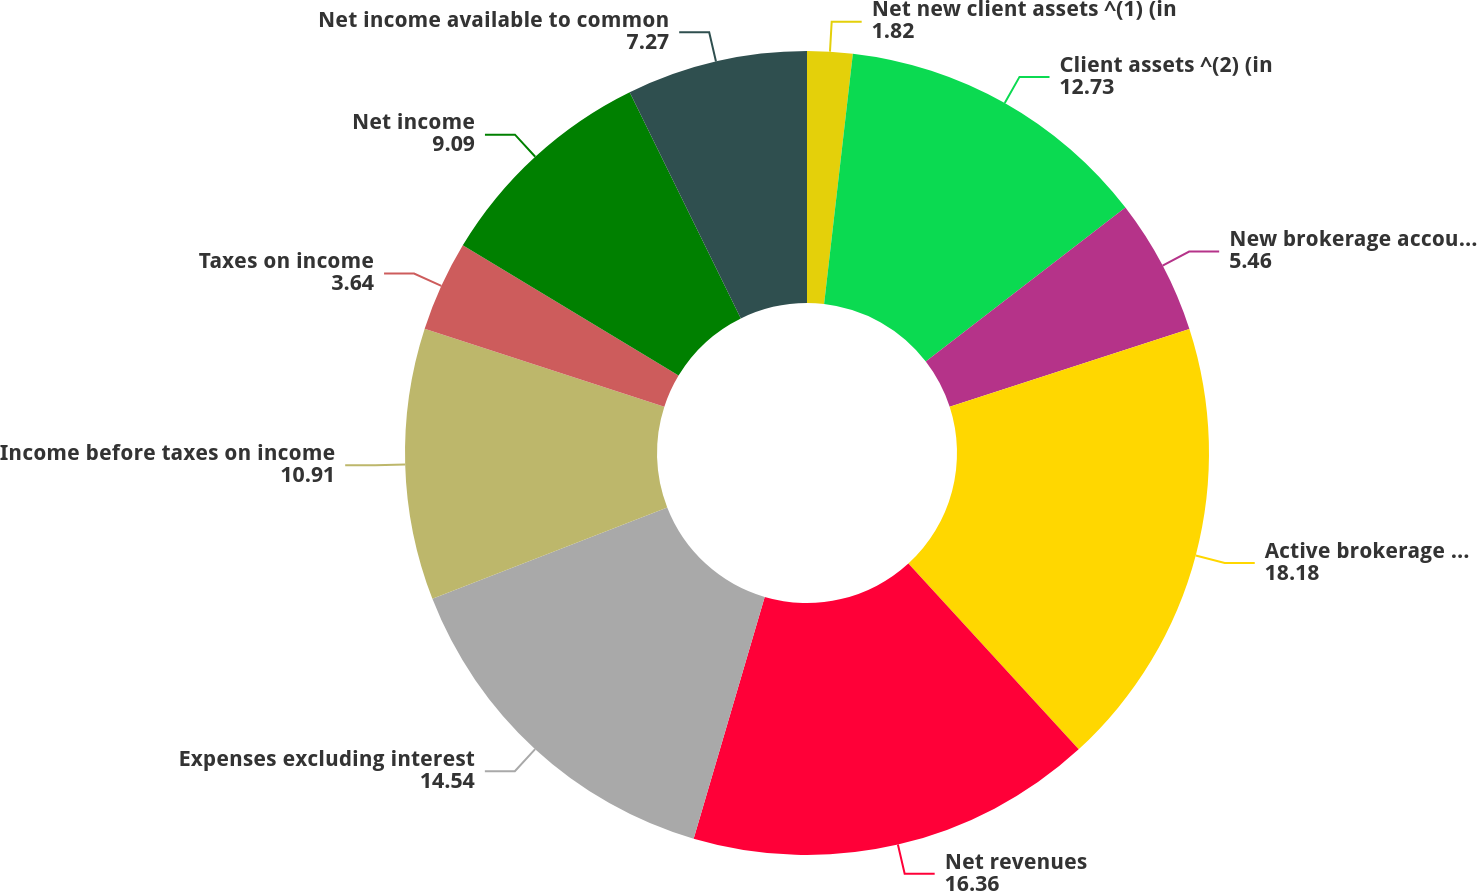Convert chart to OTSL. <chart><loc_0><loc_0><loc_500><loc_500><pie_chart><fcel>Net new client assets ^(1) (in<fcel>Client assets ^(2) (in<fcel>New brokerage accounts ^(3)<fcel>Active brokerage accounts ^(4)<fcel>Net revenues<fcel>Expenses excluding interest<fcel>Income before taxes on income<fcel>Taxes on income<fcel>Net income<fcel>Net income available to common<nl><fcel>1.82%<fcel>12.73%<fcel>5.46%<fcel>18.18%<fcel>16.36%<fcel>14.54%<fcel>10.91%<fcel>3.64%<fcel>9.09%<fcel>7.27%<nl></chart> 